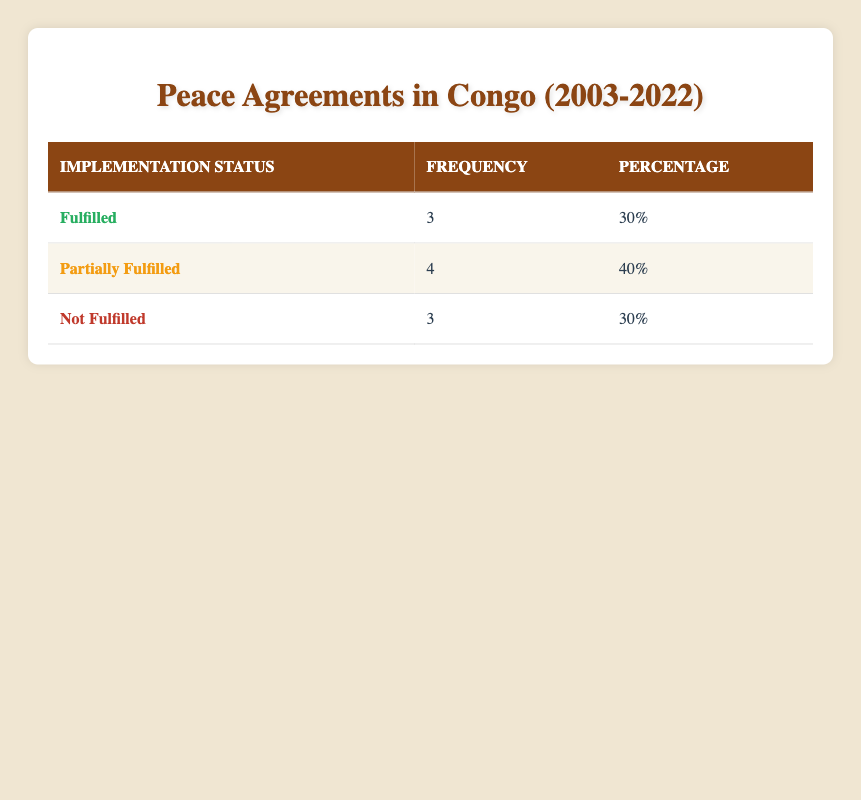What is the implementation status with the highest frequency? By looking at the frequency column, "Partially Fulfilled" has the highest frequency of 4, compared to "Fulfilled" and "Not Fulfilled" which both have a frequency of 3.
Answer: Partially Fulfilled How many agreements were fulfilled? The table shows "Fulfilled" has a frequency of 3, indicating that three agreements were reported as fulfilled.
Answer: 3 What percentage of agreements are not fulfilled? The frequency of "Not Fulfilled" is 3, and there are a total of 10 agreements. To find the percentage: (3/10) * 100 = 30%.
Answer: 30% Is there a year in which an agreement was both fulfilled and not fulfilled? The table has distinct agreements listed for each year; thus, each year indicates either fulfilled or not fulfilled without overlapping, leading to a false statement.
Answer: No What is the difference in frequency between partially fulfilled and fulfilled agreements? "Partially Fulfilled" has a frequency of 4, while "Fulfilled" has a frequency of 3. The difference is calculated as 4 - 3 = 1.
Answer: 1 How many agreements were either fulfilled or partially fulfilled? To find this, sum the frequencies of "Fulfilled" (3) and "Partially Fulfilled" (4), which gives 3 + 4 = 7 agreements.
Answer: 7 What is the total number of peace agreements recorded in the table? The table lists agreements with their implementation statuses; by adding all frequencies together: 3 (Fulfilled) + 4 (Partially Fulfilled) + 3 (Not Fulfilled) = 10 agreements.
Answer: 10 Was the "Kimberley Process Certification Scheme" agreement fulfilled? Looking at the table, this agreement has an implementation status marked as "Not Fulfilled."
Answer: No Which implementation status appears the least in the table? Both "Fulfilled" and "Not Fulfilled" have a frequency of 3, while "Partially Fulfilled" has the highest at 4. The least common statuses are "Fulfilled" and "Not Fulfilled."
Answer: Fulfilled and Not Fulfilled 